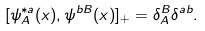Convert formula to latex. <formula><loc_0><loc_0><loc_500><loc_500>[ \psi _ { A } ^ { * a } ( x ) , \psi ^ { b B } ( x ) ] _ { + } = \delta _ { A } ^ { B } \delta ^ { a b } .</formula> 